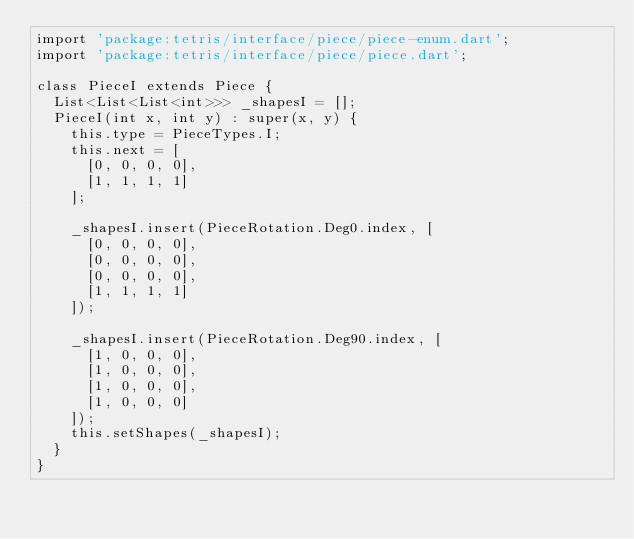Convert code to text. <code><loc_0><loc_0><loc_500><loc_500><_Dart_>import 'package:tetris/interface/piece/piece-enum.dart';
import 'package:tetris/interface/piece/piece.dart';

class PieceI extends Piece {
  List<List<List<int>>> _shapesI = [];
  PieceI(int x, int y) : super(x, y) {
    this.type = PieceTypes.I;
    this.next = [
      [0, 0, 0, 0],
      [1, 1, 1, 1]
    ];

    _shapesI.insert(PieceRotation.Deg0.index, [
      [0, 0, 0, 0],
      [0, 0, 0, 0],
      [0, 0, 0, 0],
      [1, 1, 1, 1]
    ]);

    _shapesI.insert(PieceRotation.Deg90.index, [
      [1, 0, 0, 0],
      [1, 0, 0, 0],
      [1, 0, 0, 0],
      [1, 0, 0, 0]
    ]);
    this.setShapes(_shapesI);
  }
}
</code> 